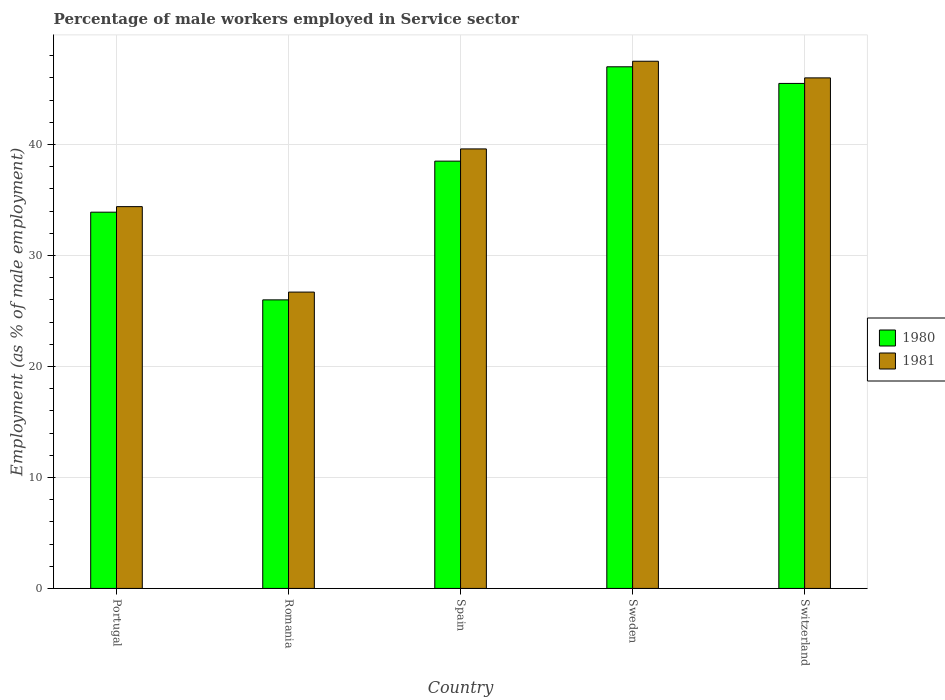How many different coloured bars are there?
Make the answer very short. 2. Are the number of bars per tick equal to the number of legend labels?
Make the answer very short. Yes. How many bars are there on the 5th tick from the right?
Offer a very short reply. 2. What is the label of the 1st group of bars from the left?
Offer a terse response. Portugal. In how many cases, is the number of bars for a given country not equal to the number of legend labels?
Keep it short and to the point. 0. What is the percentage of male workers employed in Service sector in 1980 in Portugal?
Offer a very short reply. 33.9. Across all countries, what is the maximum percentage of male workers employed in Service sector in 1981?
Ensure brevity in your answer.  47.5. Across all countries, what is the minimum percentage of male workers employed in Service sector in 1980?
Your response must be concise. 26. In which country was the percentage of male workers employed in Service sector in 1980 maximum?
Offer a very short reply. Sweden. In which country was the percentage of male workers employed in Service sector in 1980 minimum?
Keep it short and to the point. Romania. What is the total percentage of male workers employed in Service sector in 1980 in the graph?
Provide a short and direct response. 190.9. What is the difference between the percentage of male workers employed in Service sector in 1980 in Portugal and that in Switzerland?
Keep it short and to the point. -11.6. What is the difference between the percentage of male workers employed in Service sector in 1980 in Switzerland and the percentage of male workers employed in Service sector in 1981 in Portugal?
Your answer should be very brief. 11.1. What is the average percentage of male workers employed in Service sector in 1981 per country?
Provide a succinct answer. 38.84. What is the ratio of the percentage of male workers employed in Service sector in 1981 in Portugal to that in Sweden?
Ensure brevity in your answer.  0.72. Is the difference between the percentage of male workers employed in Service sector in 1981 in Portugal and Romania greater than the difference between the percentage of male workers employed in Service sector in 1980 in Portugal and Romania?
Ensure brevity in your answer.  No. What is the difference between the highest and the second highest percentage of male workers employed in Service sector in 1981?
Ensure brevity in your answer.  -6.4. What is the difference between the highest and the lowest percentage of male workers employed in Service sector in 1981?
Ensure brevity in your answer.  20.8. In how many countries, is the percentage of male workers employed in Service sector in 1980 greater than the average percentage of male workers employed in Service sector in 1980 taken over all countries?
Offer a terse response. 3. What does the 2nd bar from the right in Sweden represents?
Make the answer very short. 1980. How many bars are there?
Keep it short and to the point. 10. Are all the bars in the graph horizontal?
Provide a succinct answer. No. Are the values on the major ticks of Y-axis written in scientific E-notation?
Keep it short and to the point. No. Does the graph contain any zero values?
Your response must be concise. No. Where does the legend appear in the graph?
Keep it short and to the point. Center right. How many legend labels are there?
Provide a succinct answer. 2. How are the legend labels stacked?
Offer a terse response. Vertical. What is the title of the graph?
Give a very brief answer. Percentage of male workers employed in Service sector. Does "1964" appear as one of the legend labels in the graph?
Your answer should be compact. No. What is the label or title of the Y-axis?
Offer a very short reply. Employment (as % of male employment). What is the Employment (as % of male employment) in 1980 in Portugal?
Offer a terse response. 33.9. What is the Employment (as % of male employment) of 1981 in Portugal?
Your answer should be compact. 34.4. What is the Employment (as % of male employment) in 1980 in Romania?
Keep it short and to the point. 26. What is the Employment (as % of male employment) in 1981 in Romania?
Make the answer very short. 26.7. What is the Employment (as % of male employment) of 1980 in Spain?
Ensure brevity in your answer.  38.5. What is the Employment (as % of male employment) of 1981 in Spain?
Your response must be concise. 39.6. What is the Employment (as % of male employment) of 1980 in Sweden?
Your answer should be very brief. 47. What is the Employment (as % of male employment) of 1981 in Sweden?
Give a very brief answer. 47.5. What is the Employment (as % of male employment) of 1980 in Switzerland?
Make the answer very short. 45.5. Across all countries, what is the maximum Employment (as % of male employment) in 1980?
Offer a terse response. 47. Across all countries, what is the maximum Employment (as % of male employment) in 1981?
Provide a short and direct response. 47.5. Across all countries, what is the minimum Employment (as % of male employment) in 1981?
Ensure brevity in your answer.  26.7. What is the total Employment (as % of male employment) in 1980 in the graph?
Your answer should be compact. 190.9. What is the total Employment (as % of male employment) of 1981 in the graph?
Give a very brief answer. 194.2. What is the difference between the Employment (as % of male employment) of 1980 in Portugal and that in Romania?
Provide a succinct answer. 7.9. What is the difference between the Employment (as % of male employment) of 1981 in Portugal and that in Romania?
Offer a terse response. 7.7. What is the difference between the Employment (as % of male employment) of 1981 in Portugal and that in Spain?
Provide a short and direct response. -5.2. What is the difference between the Employment (as % of male employment) in 1981 in Portugal and that in Sweden?
Ensure brevity in your answer.  -13.1. What is the difference between the Employment (as % of male employment) in 1980 in Portugal and that in Switzerland?
Your answer should be compact. -11.6. What is the difference between the Employment (as % of male employment) in 1981 in Portugal and that in Switzerland?
Your answer should be very brief. -11.6. What is the difference between the Employment (as % of male employment) of 1980 in Romania and that in Spain?
Provide a succinct answer. -12.5. What is the difference between the Employment (as % of male employment) of 1981 in Romania and that in Spain?
Provide a short and direct response. -12.9. What is the difference between the Employment (as % of male employment) in 1981 in Romania and that in Sweden?
Your response must be concise. -20.8. What is the difference between the Employment (as % of male employment) in 1980 in Romania and that in Switzerland?
Provide a short and direct response. -19.5. What is the difference between the Employment (as % of male employment) in 1981 in Romania and that in Switzerland?
Offer a terse response. -19.3. What is the difference between the Employment (as % of male employment) in 1980 in Spain and that in Sweden?
Make the answer very short. -8.5. What is the difference between the Employment (as % of male employment) in 1981 in Spain and that in Switzerland?
Offer a terse response. -6.4. What is the difference between the Employment (as % of male employment) in 1981 in Sweden and that in Switzerland?
Give a very brief answer. 1.5. What is the difference between the Employment (as % of male employment) in 1980 in Portugal and the Employment (as % of male employment) in 1981 in Spain?
Give a very brief answer. -5.7. What is the difference between the Employment (as % of male employment) in 1980 in Portugal and the Employment (as % of male employment) in 1981 in Sweden?
Provide a succinct answer. -13.6. What is the difference between the Employment (as % of male employment) of 1980 in Portugal and the Employment (as % of male employment) of 1981 in Switzerland?
Offer a very short reply. -12.1. What is the difference between the Employment (as % of male employment) in 1980 in Romania and the Employment (as % of male employment) in 1981 in Spain?
Provide a succinct answer. -13.6. What is the difference between the Employment (as % of male employment) in 1980 in Romania and the Employment (as % of male employment) in 1981 in Sweden?
Make the answer very short. -21.5. What is the difference between the Employment (as % of male employment) in 1980 in Romania and the Employment (as % of male employment) in 1981 in Switzerland?
Provide a succinct answer. -20. What is the difference between the Employment (as % of male employment) of 1980 in Sweden and the Employment (as % of male employment) of 1981 in Switzerland?
Your response must be concise. 1. What is the average Employment (as % of male employment) in 1980 per country?
Provide a succinct answer. 38.18. What is the average Employment (as % of male employment) in 1981 per country?
Give a very brief answer. 38.84. What is the difference between the Employment (as % of male employment) of 1980 and Employment (as % of male employment) of 1981 in Spain?
Provide a short and direct response. -1.1. What is the difference between the Employment (as % of male employment) in 1980 and Employment (as % of male employment) in 1981 in Switzerland?
Keep it short and to the point. -0.5. What is the ratio of the Employment (as % of male employment) of 1980 in Portugal to that in Romania?
Offer a very short reply. 1.3. What is the ratio of the Employment (as % of male employment) of 1981 in Portugal to that in Romania?
Provide a short and direct response. 1.29. What is the ratio of the Employment (as % of male employment) in 1980 in Portugal to that in Spain?
Your answer should be compact. 0.88. What is the ratio of the Employment (as % of male employment) in 1981 in Portugal to that in Spain?
Offer a very short reply. 0.87. What is the ratio of the Employment (as % of male employment) in 1980 in Portugal to that in Sweden?
Your response must be concise. 0.72. What is the ratio of the Employment (as % of male employment) in 1981 in Portugal to that in Sweden?
Keep it short and to the point. 0.72. What is the ratio of the Employment (as % of male employment) in 1980 in Portugal to that in Switzerland?
Keep it short and to the point. 0.75. What is the ratio of the Employment (as % of male employment) of 1981 in Portugal to that in Switzerland?
Provide a succinct answer. 0.75. What is the ratio of the Employment (as % of male employment) in 1980 in Romania to that in Spain?
Provide a short and direct response. 0.68. What is the ratio of the Employment (as % of male employment) in 1981 in Romania to that in Spain?
Your answer should be compact. 0.67. What is the ratio of the Employment (as % of male employment) in 1980 in Romania to that in Sweden?
Your answer should be very brief. 0.55. What is the ratio of the Employment (as % of male employment) in 1981 in Romania to that in Sweden?
Your answer should be very brief. 0.56. What is the ratio of the Employment (as % of male employment) of 1981 in Romania to that in Switzerland?
Offer a terse response. 0.58. What is the ratio of the Employment (as % of male employment) of 1980 in Spain to that in Sweden?
Offer a very short reply. 0.82. What is the ratio of the Employment (as % of male employment) in 1981 in Spain to that in Sweden?
Provide a short and direct response. 0.83. What is the ratio of the Employment (as % of male employment) of 1980 in Spain to that in Switzerland?
Give a very brief answer. 0.85. What is the ratio of the Employment (as % of male employment) in 1981 in Spain to that in Switzerland?
Provide a succinct answer. 0.86. What is the ratio of the Employment (as % of male employment) in 1980 in Sweden to that in Switzerland?
Give a very brief answer. 1.03. What is the ratio of the Employment (as % of male employment) of 1981 in Sweden to that in Switzerland?
Offer a terse response. 1.03. What is the difference between the highest and the second highest Employment (as % of male employment) in 1980?
Provide a short and direct response. 1.5. What is the difference between the highest and the second highest Employment (as % of male employment) of 1981?
Ensure brevity in your answer.  1.5. What is the difference between the highest and the lowest Employment (as % of male employment) of 1981?
Your answer should be compact. 20.8. 